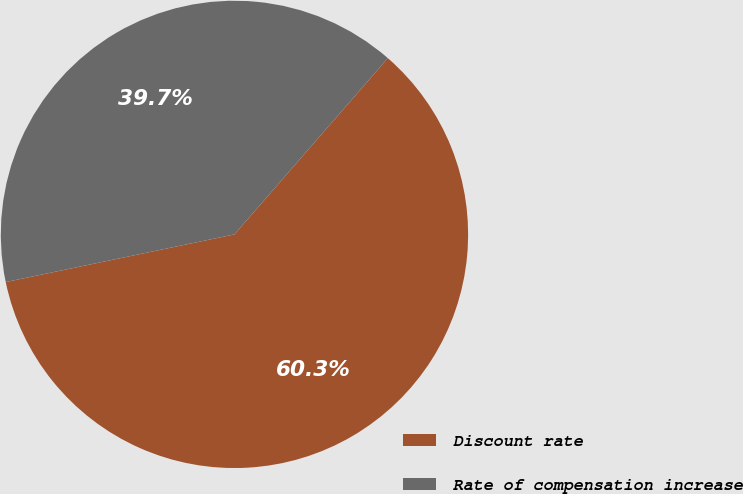Convert chart to OTSL. <chart><loc_0><loc_0><loc_500><loc_500><pie_chart><fcel>Discount rate<fcel>Rate of compensation increase<nl><fcel>60.33%<fcel>39.67%<nl></chart> 